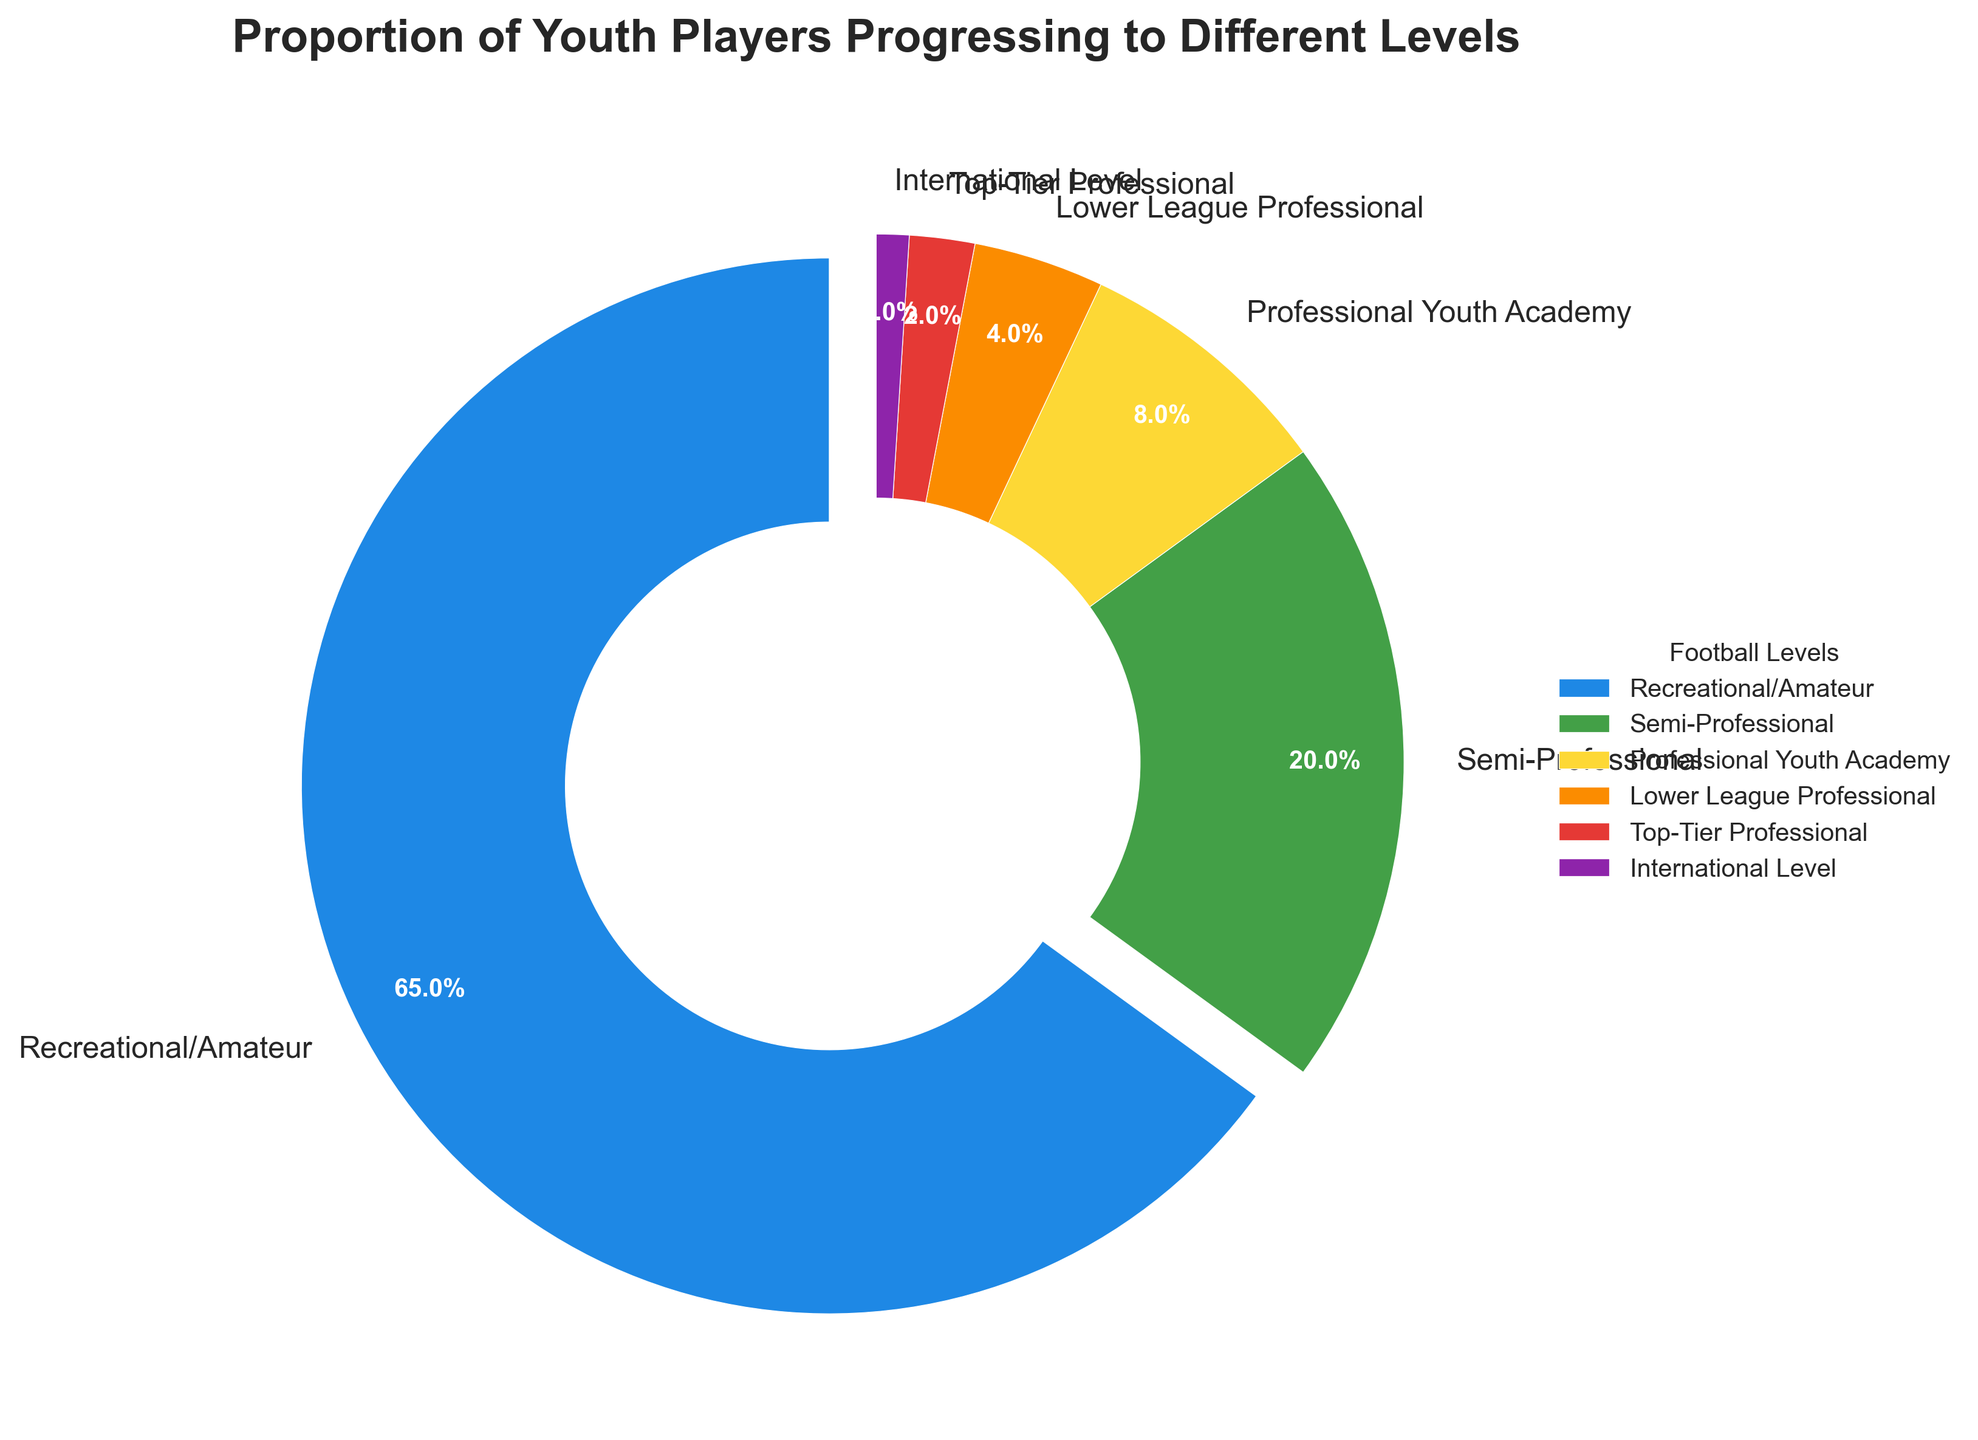What percentage of youth players progress to a Semi-Professional level? Referring to the figure, find the label "Semi-Professional" and read the percentage next to it.
Answer: 20% Sum the percentages of players that reach a Professional Youth Academy, Lower League Professional, Top-Tier Professional, and International Level. Add the percentages of players in the Professional Youth Academy (8%), Lower League Professional (4%), Top-Tier Professional (2%), and International Level (1%) categories: 8 + 4 + 2 + 1.
Answer: 15% Which level has the highest proportion of youth players? Look at the figure to identify which section has the largest slice and corresponding percentage.
Answer: Recreational/Amateur How does the proportion of youth players who reach a Professional Youth Academy compare to those who reach a Semi-Professional level? Compare the percentages next to the labels "Semi-Professional" (20%) and "Professional Youth Academy" (8%).
Answer: Semi-Professional is higher Which level slice is represented in blue on the pie chart? Identify the color blue in the pie chart and read the corresponding label.
Answer: Recreational/Amateur By how much is the percentage of players at the Semi-Professional level greater than the combined percentages of Top-Tier Professional and International Level players? Subtract the combined percentages of Top-Tier Professional (2%) and International Level (1%) from the Semi-Professional percentage (20%): 20 - (2 + 1).
Answer: 17% What proportion of youth players do not progress beyond the Recreational/Amateur or Semi-Professional levels? Add the percentages of players in Recreational/Amateur (65%) and Semi-Professional (20%) categories: 65 + 20.
Answer: 85% Compare the percentage of players who progress to a Lower League Professional level to those who progress to a Top-Tier Professional level. Compare the percentages next to the labels "Lower League Professional" (4%) and "Top-Tier Professional" (2%).
Answer: Lower League Professional is higher What is the color associated with the Top-Tier Professional level in the pie chart? Identify the section of the pie chart labeled "Top-Tier Professional" and note the color used.
Answer: Red 